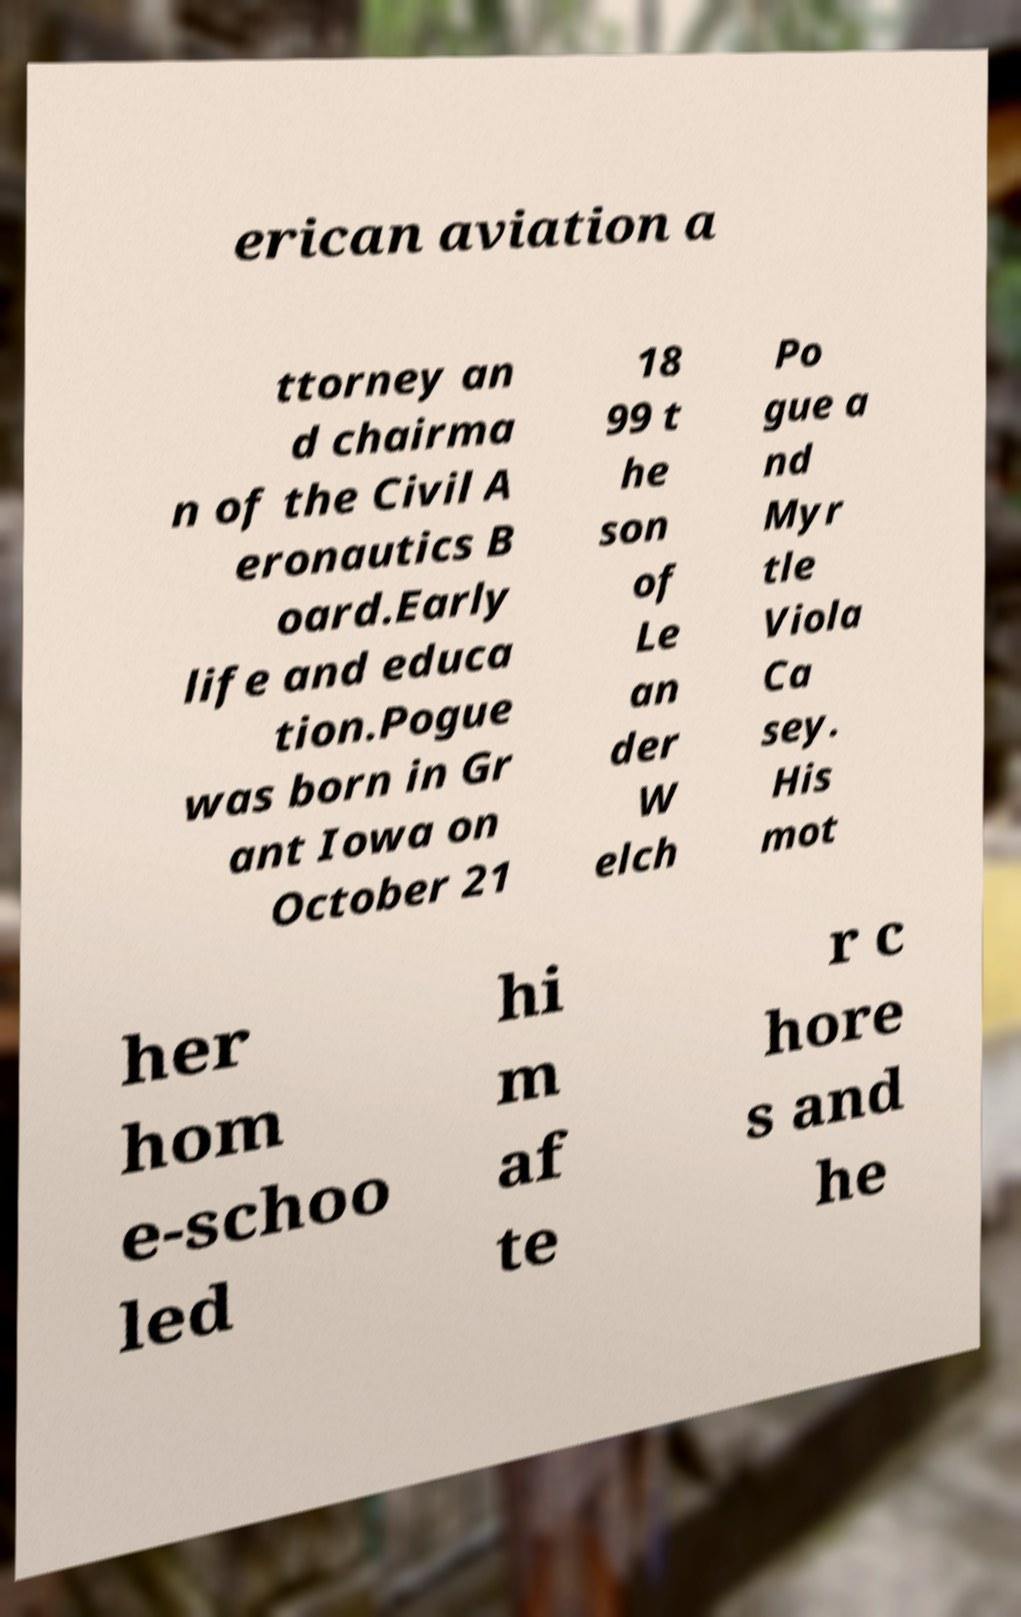Can you read and provide the text displayed in the image?This photo seems to have some interesting text. Can you extract and type it out for me? erican aviation a ttorney an d chairma n of the Civil A eronautics B oard.Early life and educa tion.Pogue was born in Gr ant Iowa on October 21 18 99 t he son of Le an der W elch Po gue a nd Myr tle Viola Ca sey. His mot her hom e-schoo led hi m af te r c hore s and he 